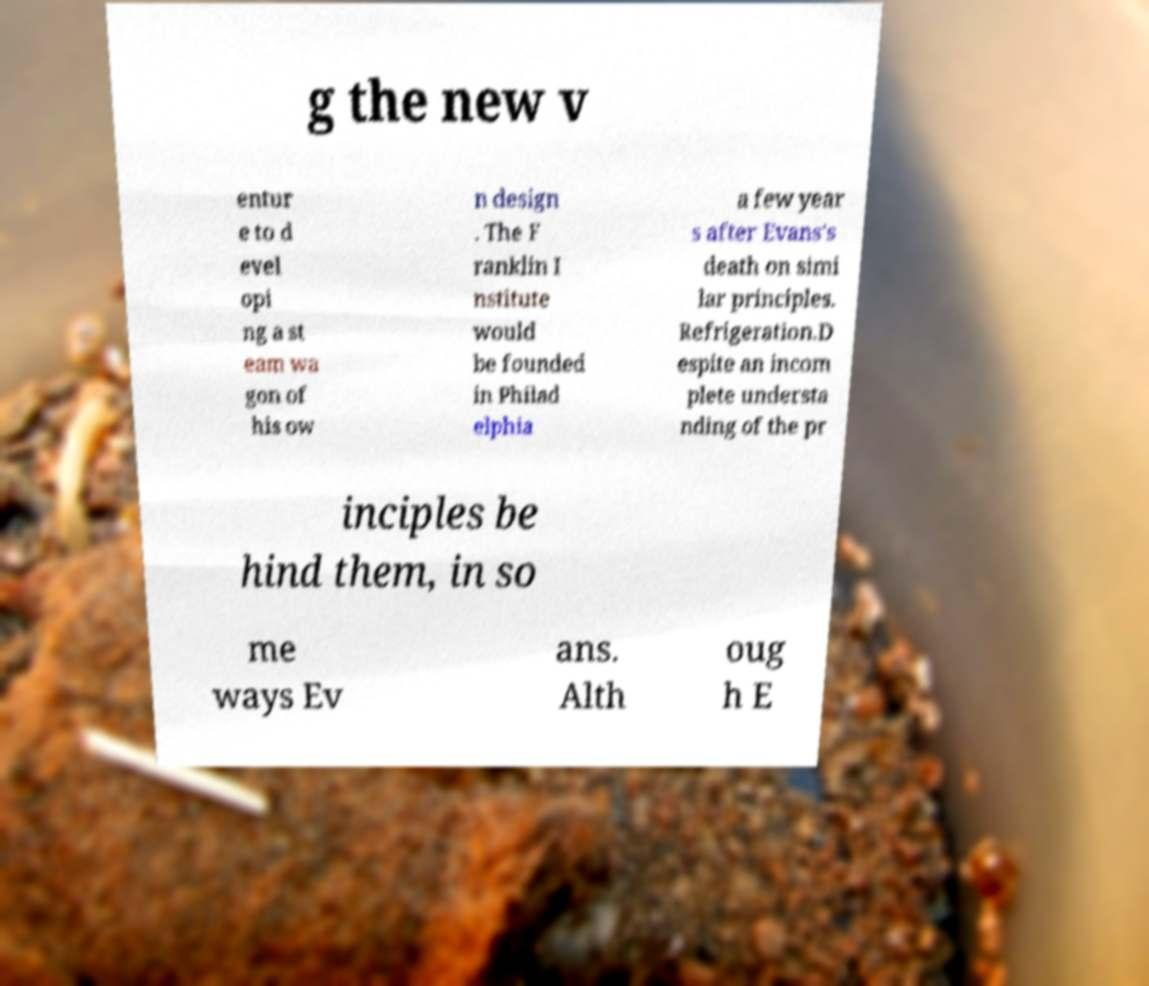Can you accurately transcribe the text from the provided image for me? g the new v entur e to d evel opi ng a st eam wa gon of his ow n design . The F ranklin I nstitute would be founded in Philad elphia a few year s after Evans's death on simi lar principles. Refrigeration.D espite an incom plete understa nding of the pr inciples be hind them, in so me ways Ev ans. Alth oug h E 